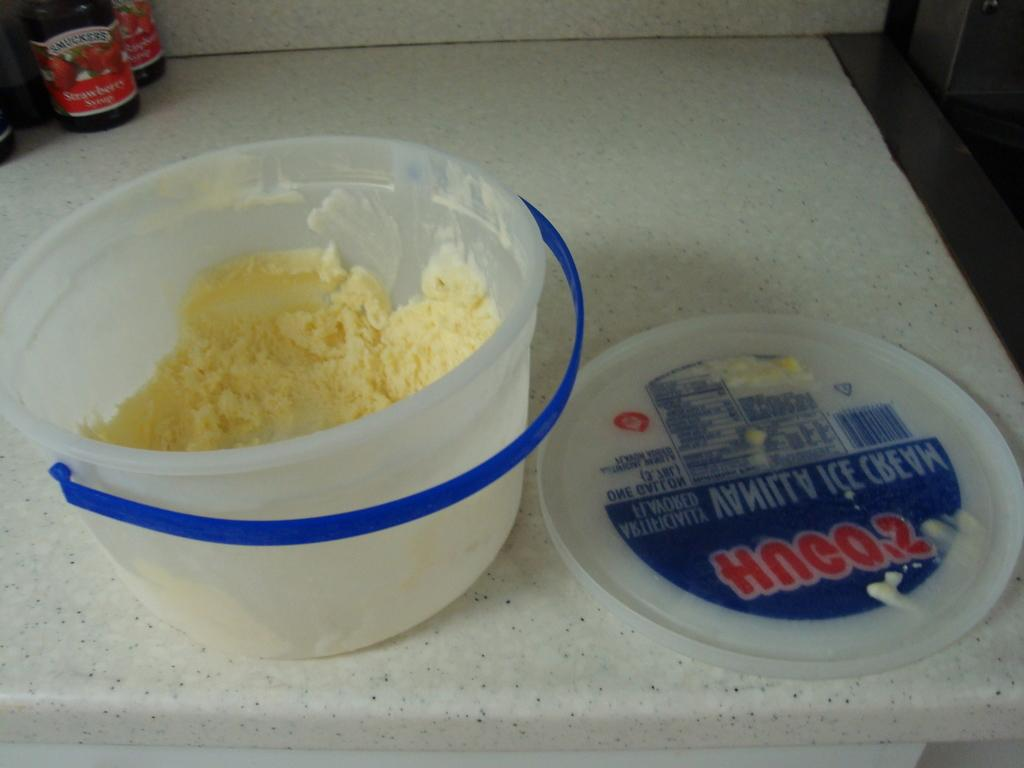What is the main subject of the picture? The main subject of the picture is an ice cream. How is the ice cream being stored or contained? The ice cream is placed in a box. Where is the box with the ice cream located? The box is on a desk. What else can be seen in the image besides the ice cream and the box? There are bottles visible in the top left side of the image. Can you hear the thunder in the image? There is no thunder present in the image; it is a still picture of an ice cream in a box on a desk. 